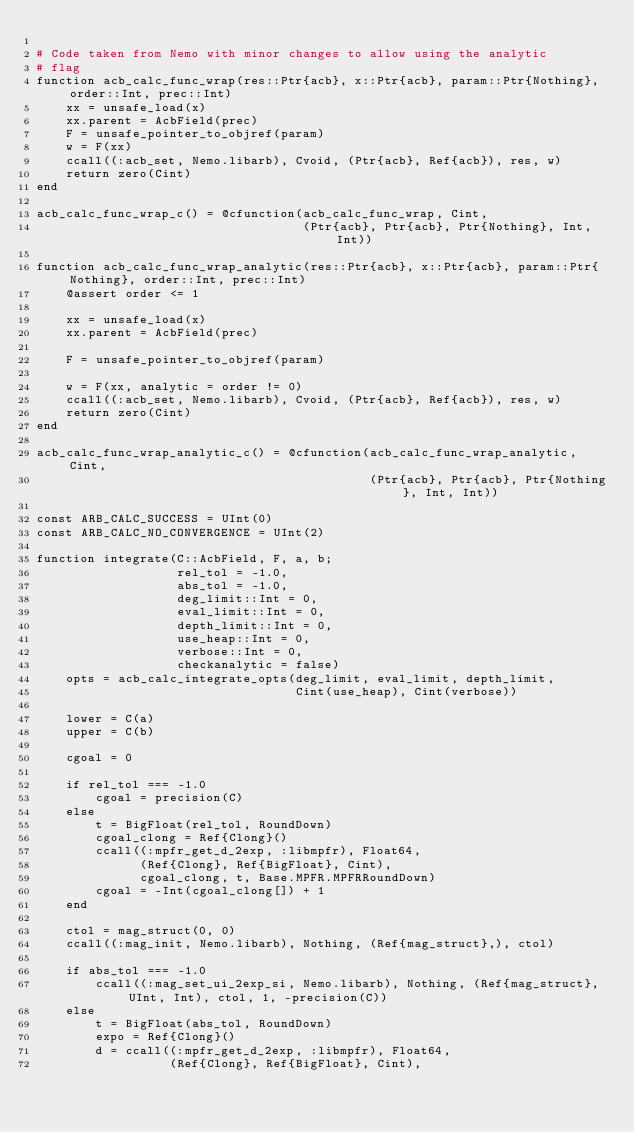Convert code to text. <code><loc_0><loc_0><loc_500><loc_500><_Julia_>
# Code taken from Nemo with minor changes to allow using the analytic
# flag
function acb_calc_func_wrap(res::Ptr{acb}, x::Ptr{acb}, param::Ptr{Nothing}, order::Int, prec::Int)
    xx = unsafe_load(x)
    xx.parent = AcbField(prec)
    F = unsafe_pointer_to_objref(param)
    w = F(xx)
    ccall((:acb_set, Nemo.libarb), Cvoid, (Ptr{acb}, Ref{acb}), res, w)
    return zero(Cint)
end

acb_calc_func_wrap_c() = @cfunction(acb_calc_func_wrap, Cint,
                                    (Ptr{acb}, Ptr{acb}, Ptr{Nothing}, Int, Int))

function acb_calc_func_wrap_analytic(res::Ptr{acb}, x::Ptr{acb}, param::Ptr{Nothing}, order::Int, prec::Int)
    @assert order <= 1

    xx = unsafe_load(x)
    xx.parent = AcbField(prec)

    F = unsafe_pointer_to_objref(param)

    w = F(xx, analytic = order != 0)
    ccall((:acb_set, Nemo.libarb), Cvoid, (Ptr{acb}, Ref{acb}), res, w)
    return zero(Cint)
end

acb_calc_func_wrap_analytic_c() = @cfunction(acb_calc_func_wrap_analytic, Cint,
                                             (Ptr{acb}, Ptr{acb}, Ptr{Nothing}, Int, Int))

const ARB_CALC_SUCCESS = UInt(0)
const ARB_CALC_NO_CONVERGENCE = UInt(2)

function integrate(C::AcbField, F, a, b;
                   rel_tol = -1.0,
                   abs_tol = -1.0,
                   deg_limit::Int = 0,
                   eval_limit::Int = 0,
                   depth_limit::Int = 0,
                   use_heap::Int = 0,
                   verbose::Int = 0,
                   checkanalytic = false)
    opts = acb_calc_integrate_opts(deg_limit, eval_limit, depth_limit,
                                   Cint(use_heap), Cint(verbose))

    lower = C(a)
    upper = C(b)

    cgoal = 0

    if rel_tol === -1.0
        cgoal = precision(C)
    else
        t = BigFloat(rel_tol, RoundDown)
        cgoal_clong = Ref{Clong}()
        ccall((:mpfr_get_d_2exp, :libmpfr), Float64,
              (Ref{Clong}, Ref{BigFloat}, Cint),
              cgoal_clong, t, Base.MPFR.MPFRRoundDown)
        cgoal = -Int(cgoal_clong[]) + 1
    end

    ctol = mag_struct(0, 0)
    ccall((:mag_init, Nemo.libarb), Nothing, (Ref{mag_struct},), ctol)

    if abs_tol === -1.0
        ccall((:mag_set_ui_2exp_si, Nemo.libarb), Nothing, (Ref{mag_struct}, UInt, Int), ctol, 1, -precision(C))
    else
        t = BigFloat(abs_tol, RoundDown)
        expo = Ref{Clong}()
        d = ccall((:mpfr_get_d_2exp, :libmpfr), Float64,
                  (Ref{Clong}, Ref{BigFloat}, Cint),</code> 